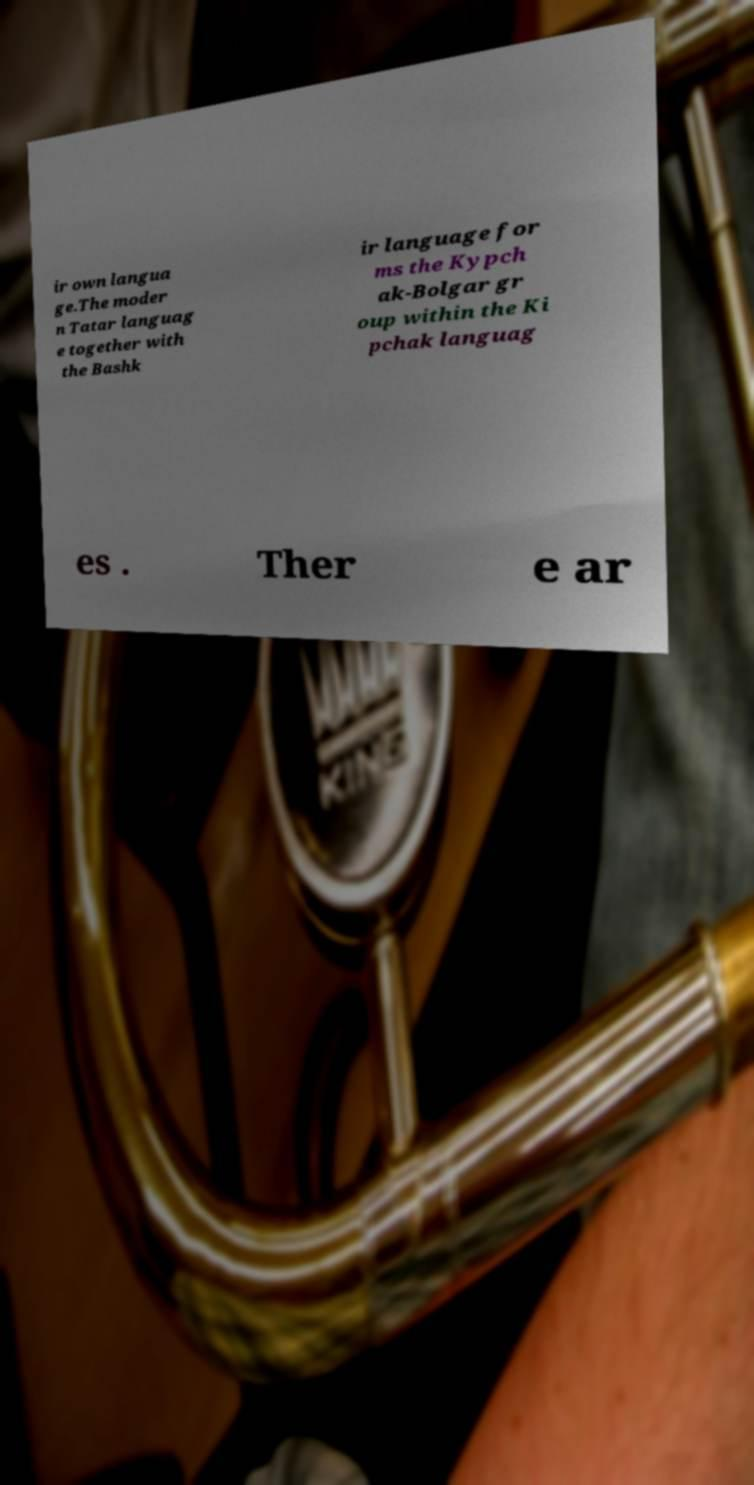What messages or text are displayed in this image? I need them in a readable, typed format. ir own langua ge.The moder n Tatar languag e together with the Bashk ir language for ms the Kypch ak-Bolgar gr oup within the Ki pchak languag es . Ther e ar 